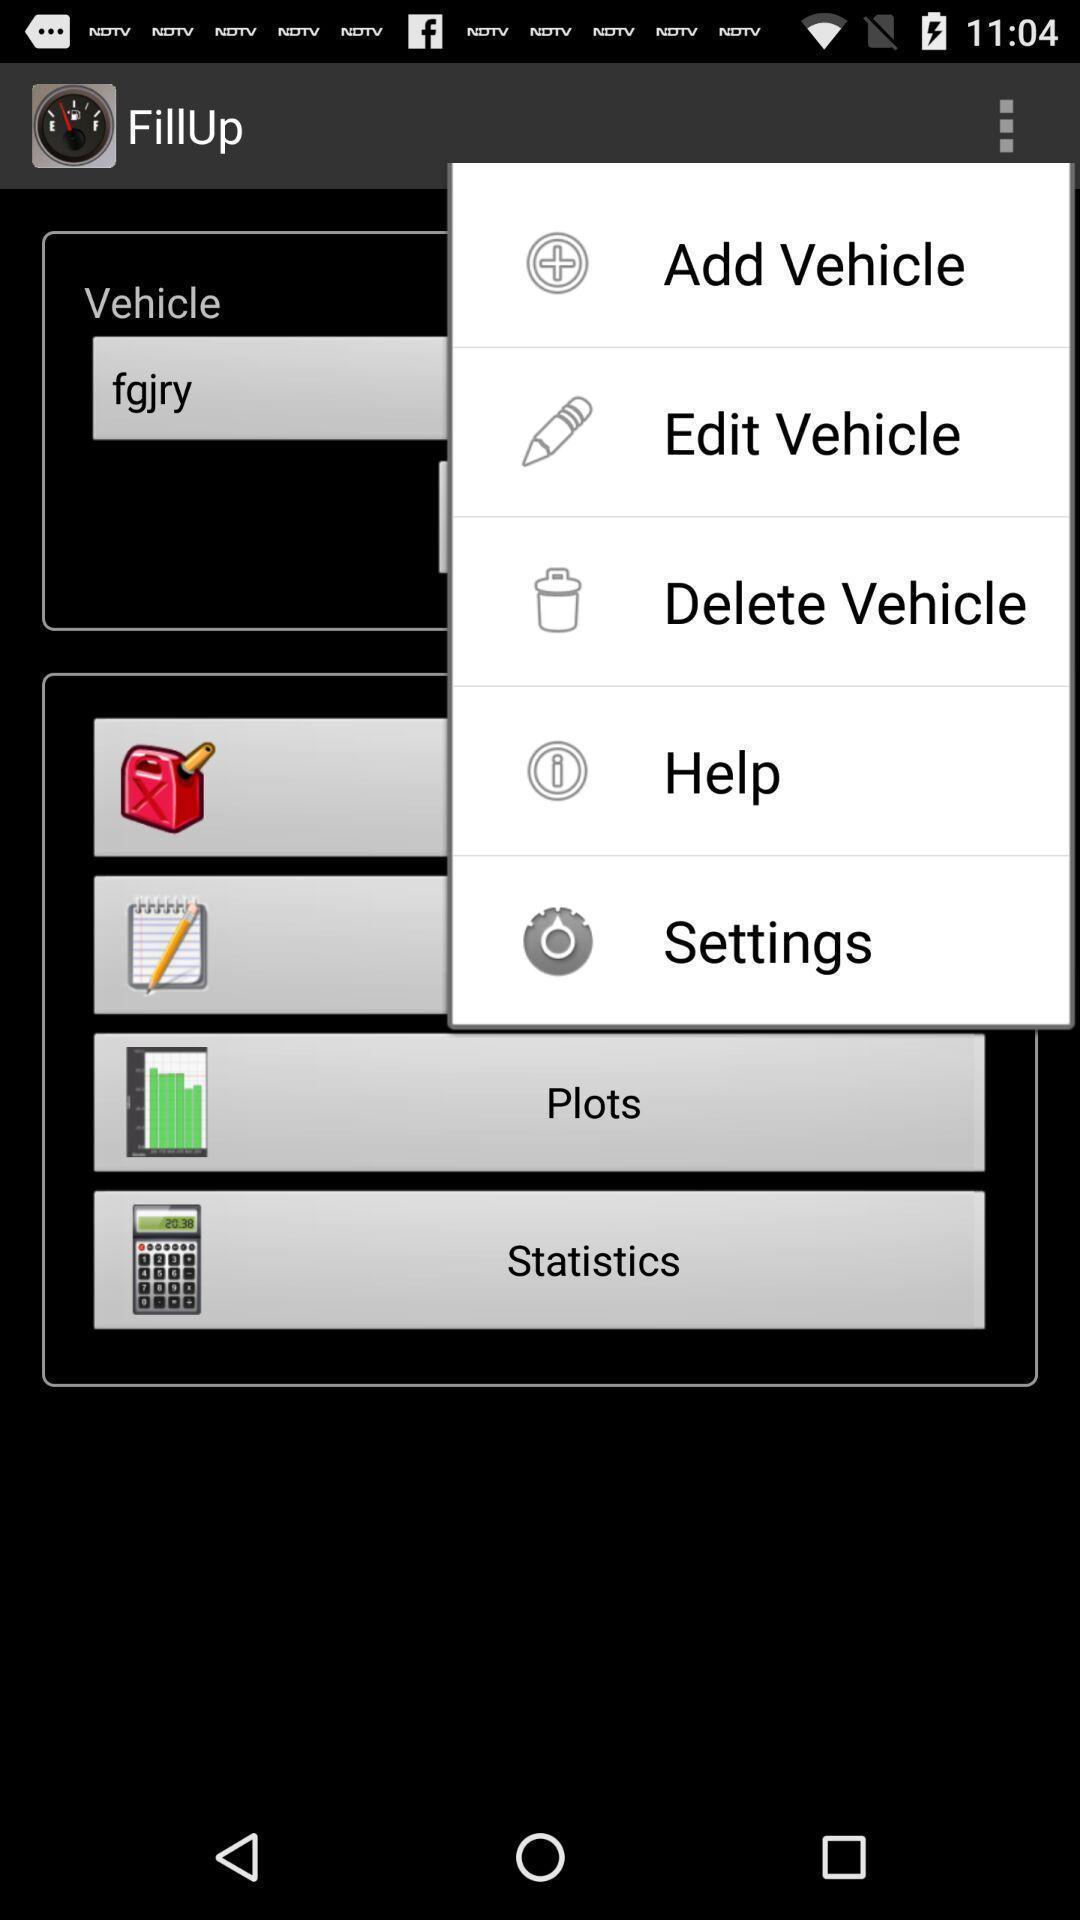Tell me about the visual elements in this screen capture. Screen shows list of options in a fuel app. 